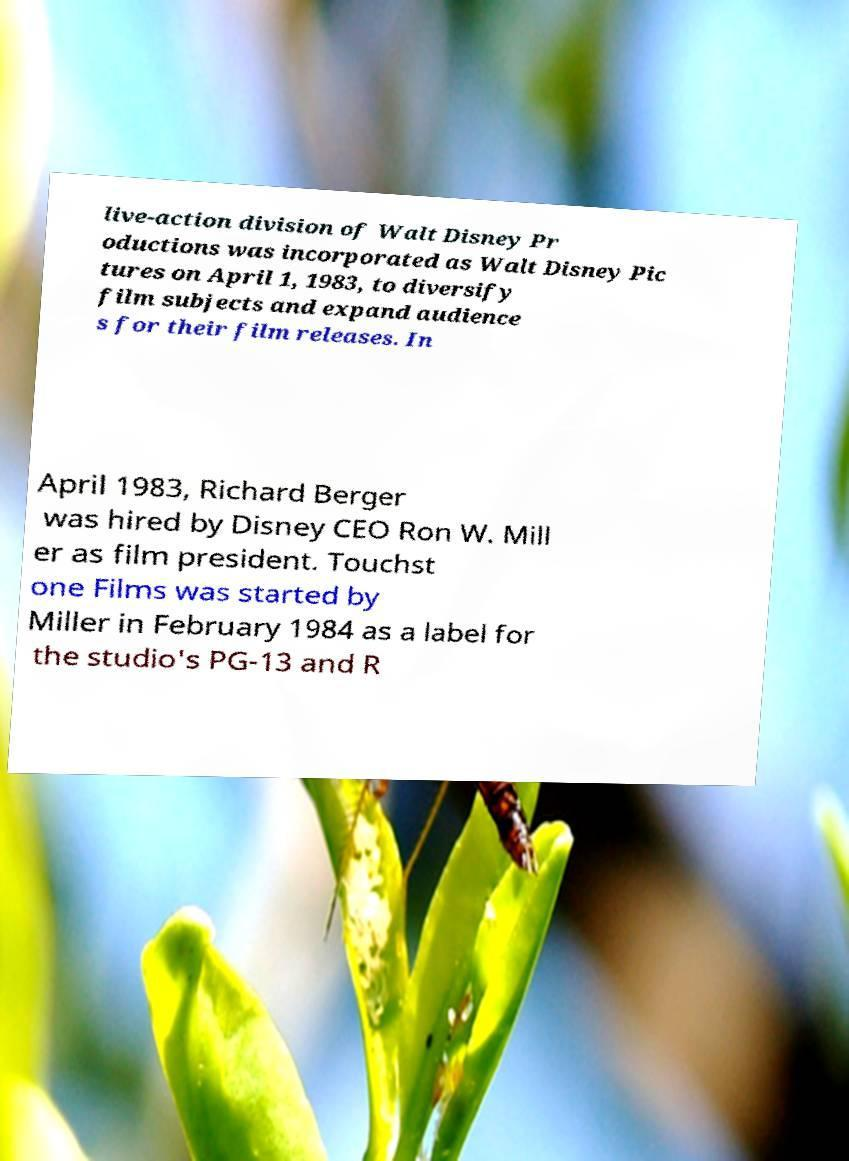Please identify and transcribe the text found in this image. live-action division of Walt Disney Pr oductions was incorporated as Walt Disney Pic tures on April 1, 1983, to diversify film subjects and expand audience s for their film releases. In April 1983, Richard Berger was hired by Disney CEO Ron W. Mill er as film president. Touchst one Films was started by Miller in February 1984 as a label for the studio's PG-13 and R 